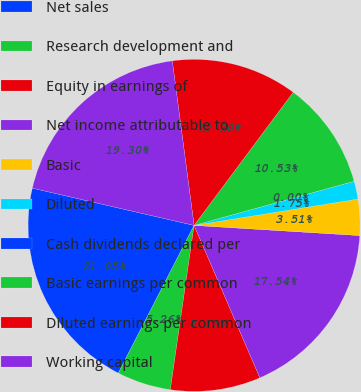<chart> <loc_0><loc_0><loc_500><loc_500><pie_chart><fcel>Net sales<fcel>Research development and<fcel>Equity in earnings of<fcel>Net income attributable to<fcel>Basic<fcel>Diluted<fcel>Cash dividends declared per<fcel>Basic earnings per common<fcel>Diluted earnings per common<fcel>Working capital<nl><fcel>21.05%<fcel>5.26%<fcel>8.77%<fcel>17.54%<fcel>3.51%<fcel>1.75%<fcel>0.0%<fcel>10.53%<fcel>12.28%<fcel>19.3%<nl></chart> 